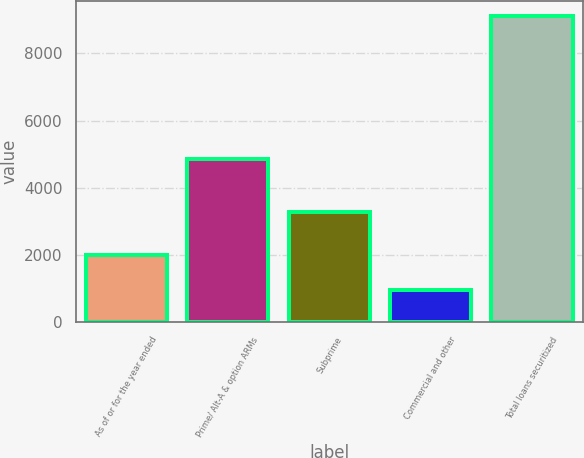Convert chart to OTSL. <chart><loc_0><loc_0><loc_500><loc_500><bar_chart><fcel>As of or for the year ended<fcel>Prime/ Alt-A & option ARMs<fcel>Subprime<fcel>Commercial and other<fcel>Total loans securitized<nl><fcel>2017<fcel>4870<fcel>3276<fcel>957<fcel>9103<nl></chart> 